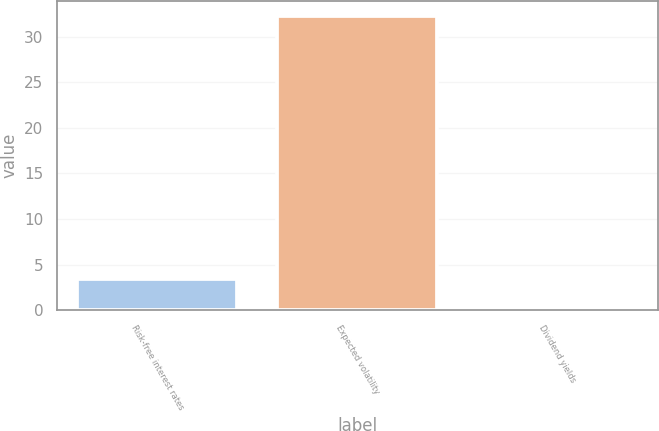Convert chart. <chart><loc_0><loc_0><loc_500><loc_500><bar_chart><fcel>Risk-free interest rates<fcel>Expected volatility<fcel>Dividend yields<nl><fcel>3.42<fcel>32.31<fcel>0.21<nl></chart> 